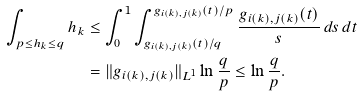<formula> <loc_0><loc_0><loc_500><loc_500>\int _ { p \leq h _ { k } \leq q } h _ { k } & \leq \int ^ { 1 } _ { 0 } \int ^ { g _ { i ( k ) , j ( k ) } ( t ) / p } _ { g _ { i ( k ) , j ( k ) } ( t ) / q } \frac { g _ { i ( k ) , j ( k ) } ( t ) } { s } \, d s \, d t \\ & = \| g _ { i ( k ) , j ( k ) } \| _ { L ^ { 1 } } \ln \frac { q } { p } \leq \ln \frac { q } { p } .</formula> 